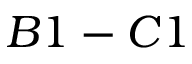<formula> <loc_0><loc_0><loc_500><loc_500>B 1 - C 1</formula> 